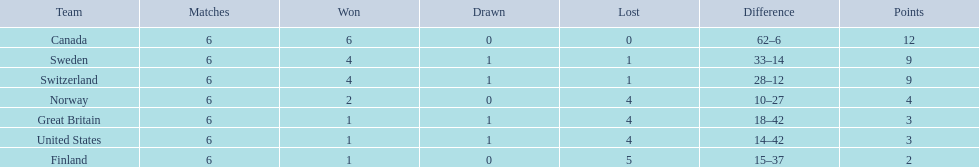What are all the teams? Canada, Sweden, Switzerland, Norway, Great Britain, United States, Finland. What were their points? 12, 9, 9, 4, 3, 3, 2. What about just switzerland and great britain? 9, 3. Now, which of those teams scored higher? Switzerland. 